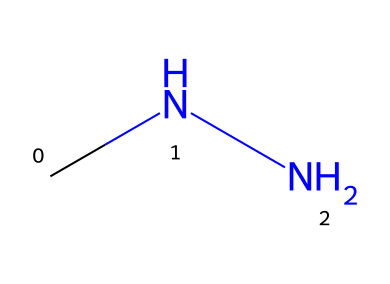What is the molecular formula of methylhydrazine? From the SMILES representation (CNN), the molecular formula can be constructed by identifying the atoms: there is one carbon (C), four hydrogens (H), and two nitrogens (N). Thus, the molecular formula is C2H8N2.
Answer: C2H8N2 How many nitrogen atoms are present in methylhydrazine? The SMILES representation (CNN) indicates there are two 'N' characters, which correspond to the presence of two nitrogen atoms in the molecule.
Answer: 2 What is the total number of atoms in methylhydrazine? Counting all atoms from the molecular formula C2H8N2, we have 2 carbon atoms, 8 hydrogen atoms, and 2 nitrogen atoms. Adding those gives a total of 12 atoms in the molecule.
Answer: 12 What is the main functional group in methylhydrazine? The structure CNN indicates it has a hydrazine functional group (N-N) in conjunction with a methyl group (C). Thus, the main functional group is hydrazine (or N-N bond).
Answer: hydrazine What type of bonding predominates in methylhydrazine? In the structure represented by the SMILES (CNN), there are single bonds between all the atoms (C-N and N-N), indicating that predominantly single covalent bonds are present in this molecule.
Answer: single covalent bonds Is methylhydrazine a saturated or unsaturated compound? The absence of double or triple bonds in the SMILES structure (CNN), leading to all carbons being connected by single bonds, indicates that methylhydrazine is a saturated compound.
Answer: saturated What is a common application of methylhydrazine in geotechnical testing? Methylhydrazine is often used as a chemical in the preparation of soil samples for testing purposes because of its reactivity.
Answer: soil testing 